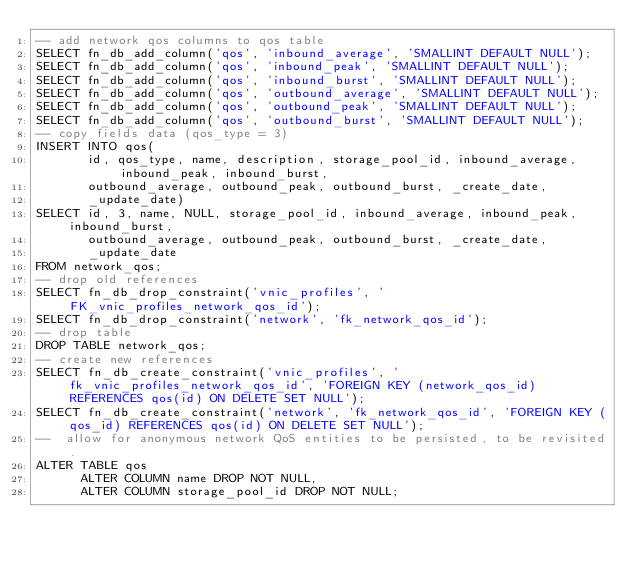<code> <loc_0><loc_0><loc_500><loc_500><_SQL_>-- add network qos columns to qos table
SELECT fn_db_add_column('qos', 'inbound_average', 'SMALLINT DEFAULT NULL');
SELECT fn_db_add_column('qos', 'inbound_peak', 'SMALLINT DEFAULT NULL');
SELECT fn_db_add_column('qos', 'inbound_burst', 'SMALLINT DEFAULT NULL');
SELECT fn_db_add_column('qos', 'outbound_average', 'SMALLINT DEFAULT NULL');
SELECT fn_db_add_column('qos', 'outbound_peak', 'SMALLINT DEFAULT NULL');
SELECT fn_db_add_column('qos', 'outbound_burst', 'SMALLINT DEFAULT NULL');
-- copy fields data (qos_type = 3)
INSERT INTO qos(
       id, qos_type, name, description, storage_pool_id, inbound_average, inbound_peak, inbound_burst,
       outbound_average, outbound_peak, outbound_burst, _create_date,
       _update_date)
SELECT id, 3, name, NULL, storage_pool_id, inbound_average, inbound_peak, inbound_burst,
       outbound_average, outbound_peak, outbound_burst, _create_date,
       _update_date
FROM network_qos;
-- drop old references
SELECT fn_db_drop_constraint('vnic_profiles', 'FK_vnic_profiles_network_qos_id');
SELECT fn_db_drop_constraint('network', 'fk_network_qos_id');
-- drop table
DROP TABLE network_qos;
-- create new references
SELECT fn_db_create_constraint('vnic_profiles', 'fk_vnic_profiles_network_qos_id', 'FOREIGN KEY (network_qos_id) REFERENCES qos(id) ON DELETE SET NULL');
SELECT fn_db_create_constraint('network', 'fk_network_qos_id', 'FOREIGN KEY (qos_id) REFERENCES qos(id) ON DELETE SET NULL');
--  allow for anonymous network QoS entities to be persisted, to be revisited.
ALTER TABLE qos
      ALTER COLUMN name DROP NOT NULL,
      ALTER COLUMN storage_pool_id DROP NOT NULL;


</code> 